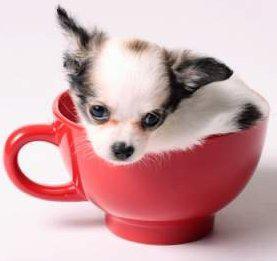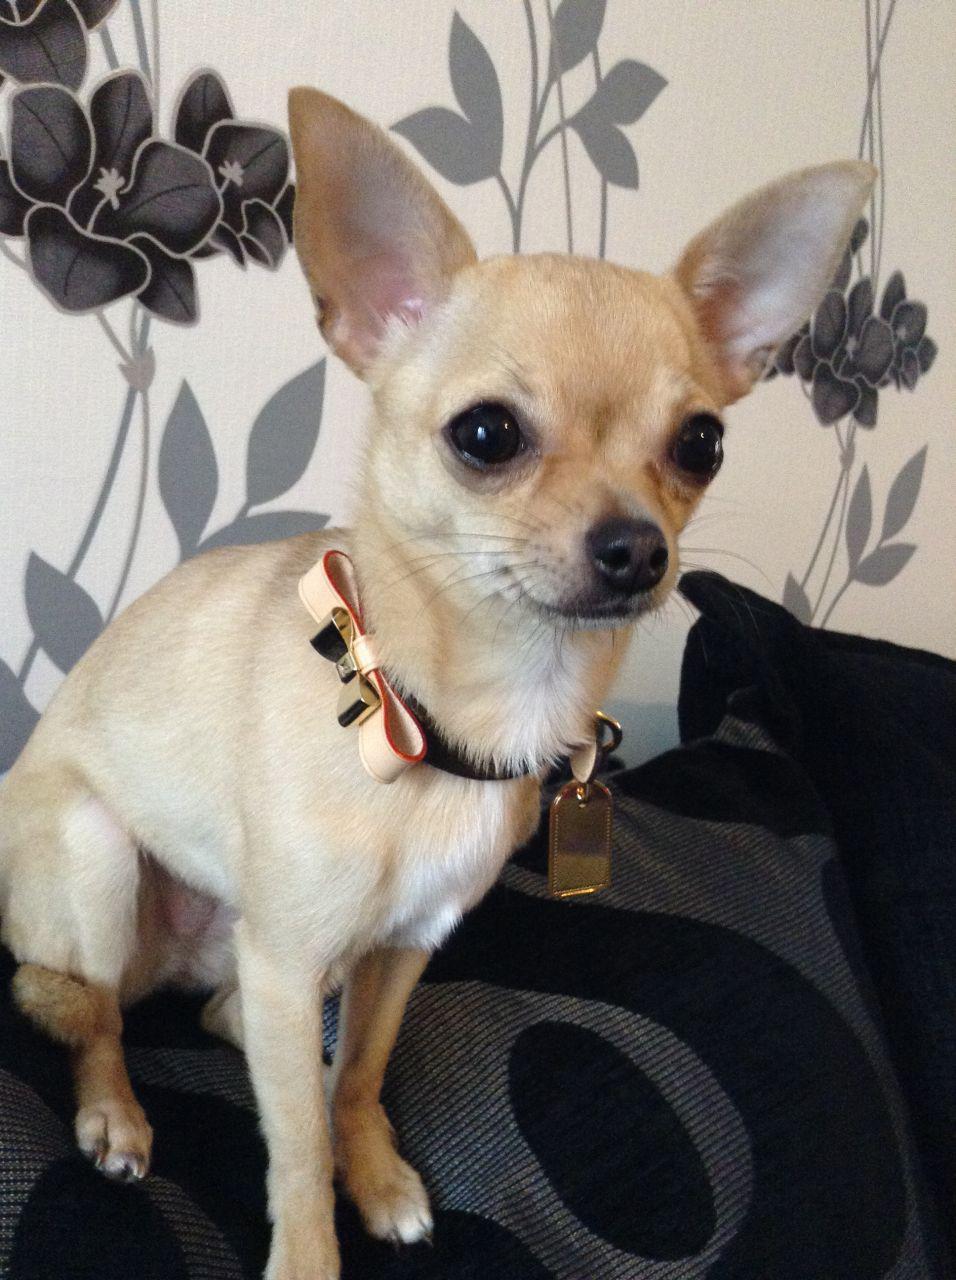The first image is the image on the left, the second image is the image on the right. For the images displayed, is the sentence "In one image, a very small dog is inside of a teacup" factually correct? Answer yes or no. Yes. The first image is the image on the left, the second image is the image on the right. Assess this claim about the two images: "The left image contains at least three chihuahuas sitting in a horizontal row.". Correct or not? Answer yes or no. No. 